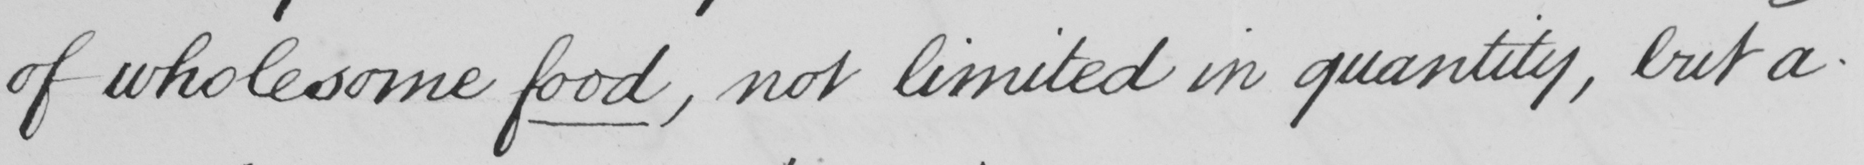Please provide the text content of this handwritten line. of wholesome food, not limited in quantity, but a- 